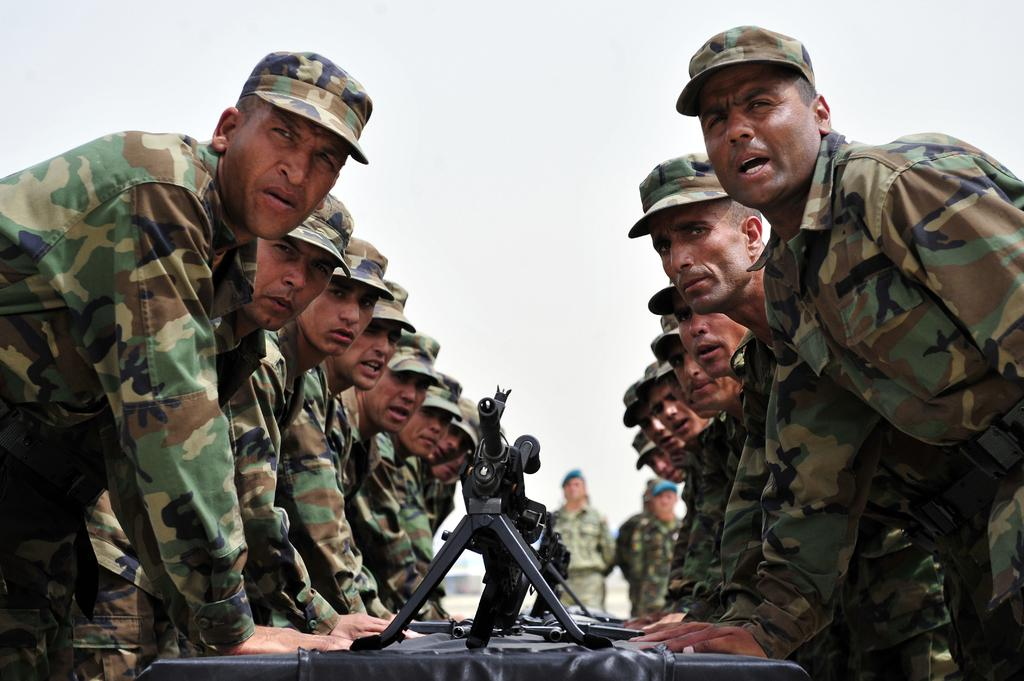What type of people are in the image? There is a group of army people in the image. Where are the army people located? The army people are on the ground. What object is present in the image that is typically associated with the military? There is a gun present in the image. Where is the gun located in the image? The gun is on a table. What type of cherry is being used as a weapon by the army people in the image? There is no cherry present in the image, and it is not being used as a weapon. 